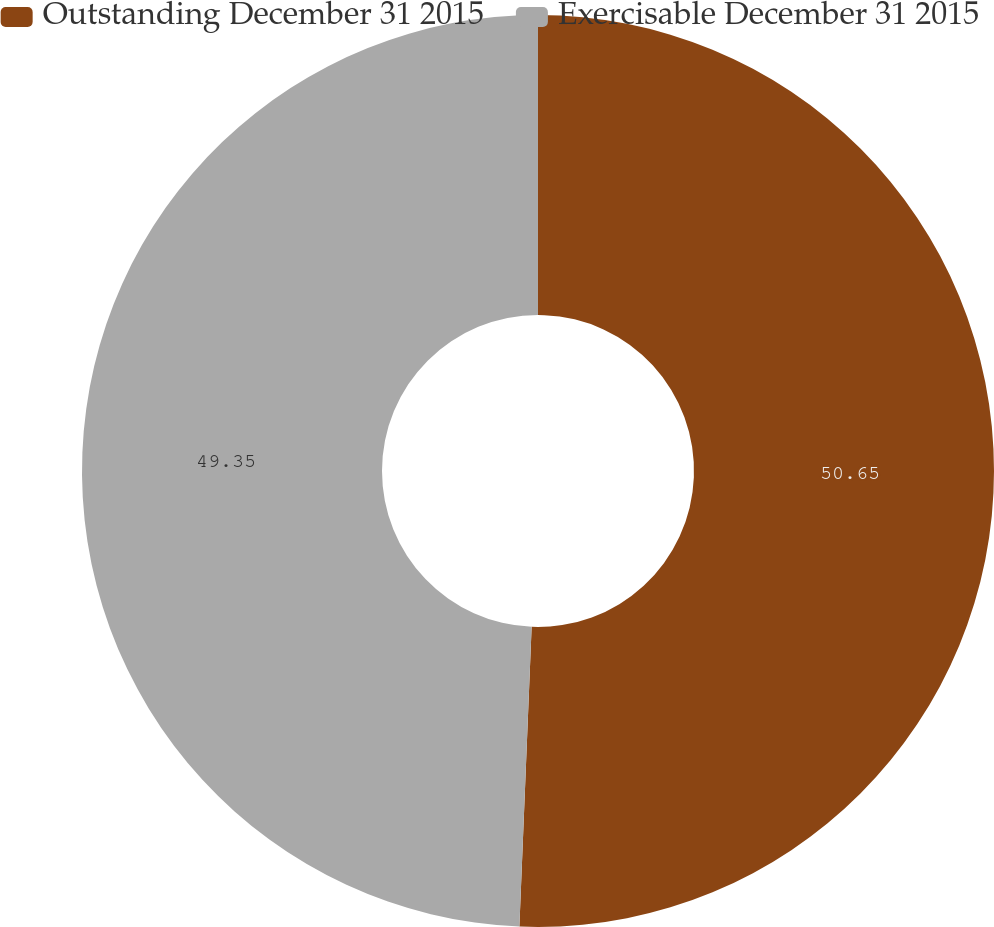Convert chart to OTSL. <chart><loc_0><loc_0><loc_500><loc_500><pie_chart><fcel>Outstanding December 31 2015<fcel>Exercisable December 31 2015<nl><fcel>50.65%<fcel>49.35%<nl></chart> 